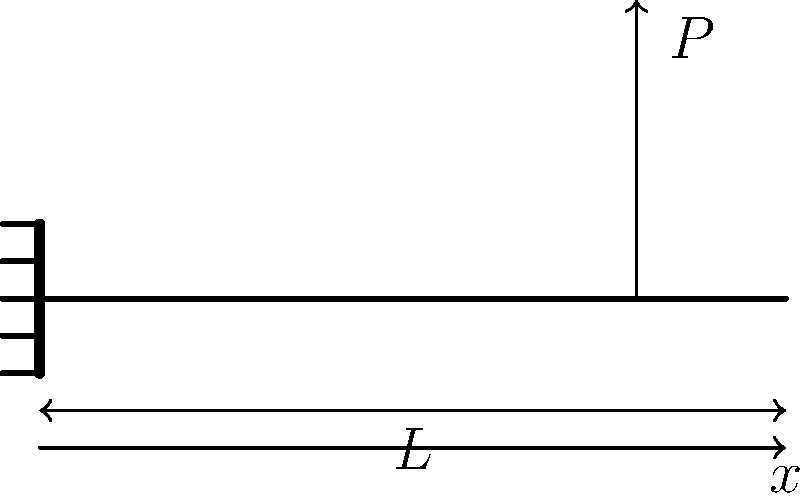Consider a cantilever beam of length $L$ with a point load $P$ applied at a distance $0.8L$ from the fixed end. Determine the expression for the bending stress $\sigma$ at a distance $x$ from the fixed end, assuming the beam has a rectangular cross-section with width $b$ and height $h$. To determine the expression for bending stress, we'll follow these steps:

1. Recall the general formula for bending stress:
   $$\sigma = \frac{My}{I}$$
   where $M$ is the bending moment, $y$ is the distance from the neutral axis, and $I$ is the moment of inertia.

2. For a rectangular cross-section:
   $$I = \frac{bh^3}{12}$$

3. The maximum stress occurs at the top and bottom surfaces, where $y = \pm \frac{h}{2}$.

4. The bending moment $M$ at a distance $x$ from the fixed end is:
   $$M = P(L - 0.8L) = 0.2PL \quad \text{for } 0 \leq x \leq 0.8L$$
   $$M = P(L - x) \quad \text{for } 0.8L < x \leq L$$

5. Substituting these into the bending stress formula:
   For $0 \leq x \leq 0.8L$:
   $$\sigma = \frac{0.2PL(\pm \frac{h}{2})}{\frac{bh^3}{12}} = \pm \frac{1.2PL}{bh^2}$$

   For $0.8L < x \leq L$:
   $$\sigma = \frac{P(L-x)(\pm \frac{h}{2})}{\frac{bh^3}{12}} = \pm \frac{6P(L-x)}{bh^2}$$

6. The maximum stress occurs at the fixed end $(x=0)$:
   $$\sigma_{max} = \pm \frac{6PL}{bh^2}$$
Answer: $\sigma = \pm \frac{1.2PL}{bh^2}$ for $0 \leq x \leq 0.8L$; $\sigma = \pm \frac{6P(L-x)}{bh^2}$ for $0.8L < x \leq L$ 